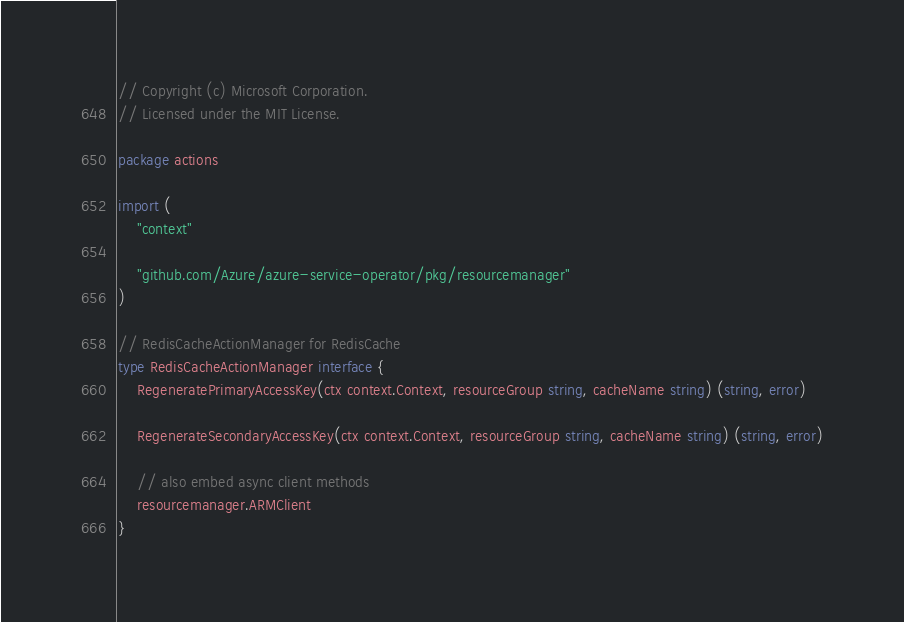Convert code to text. <code><loc_0><loc_0><loc_500><loc_500><_Go_>// Copyright (c) Microsoft Corporation.
// Licensed under the MIT License.

package actions

import (
	"context"

	"github.com/Azure/azure-service-operator/pkg/resourcemanager"
)

// RedisCacheActionManager for RedisCache
type RedisCacheActionManager interface {
	RegeneratePrimaryAccessKey(ctx context.Context, resourceGroup string, cacheName string) (string, error)

	RegenerateSecondaryAccessKey(ctx context.Context, resourceGroup string, cacheName string) (string, error)

	// also embed async client methods
	resourcemanager.ARMClient
}
</code> 